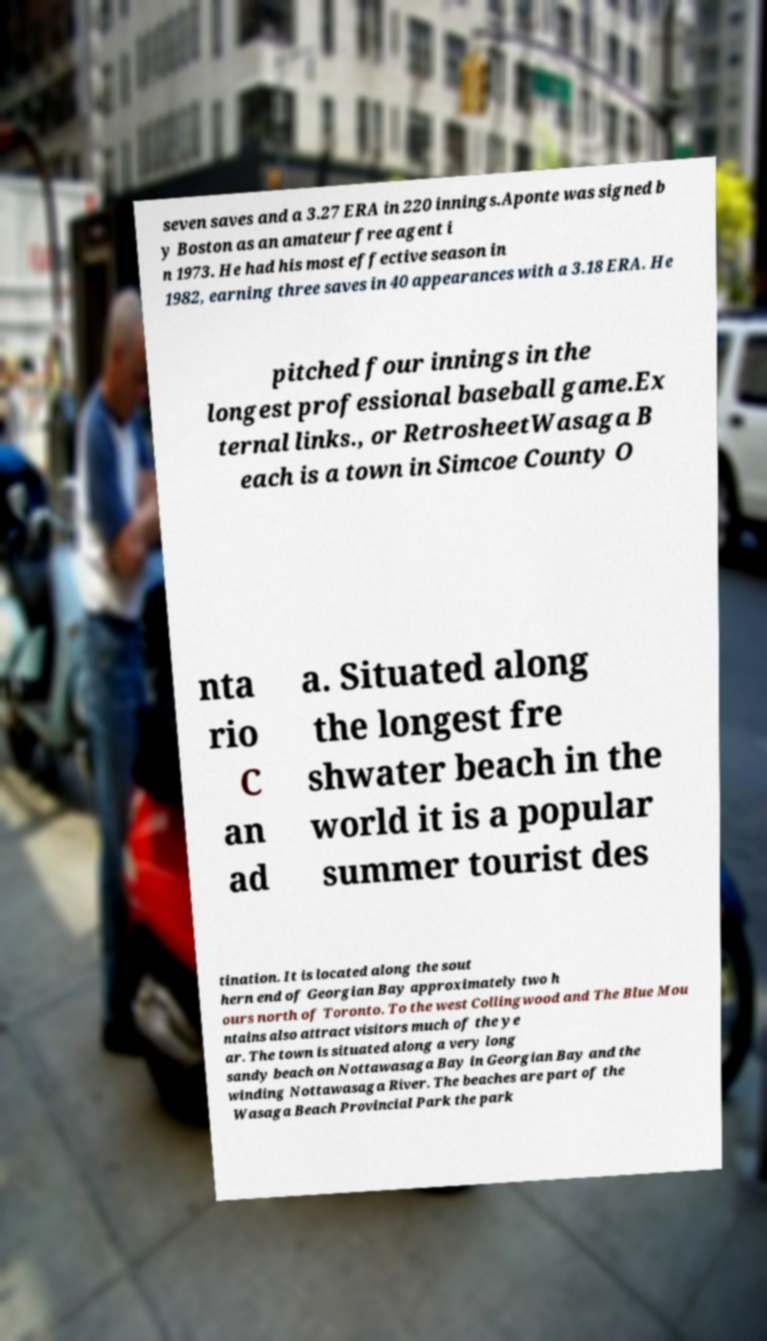Please read and relay the text visible in this image. What does it say? seven saves and a 3.27 ERA in 220 innings.Aponte was signed b y Boston as an amateur free agent i n 1973. He had his most effective season in 1982, earning three saves in 40 appearances with a 3.18 ERA. He pitched four innings in the longest professional baseball game.Ex ternal links., or RetrosheetWasaga B each is a town in Simcoe County O nta rio C an ad a. Situated along the longest fre shwater beach in the world it is a popular summer tourist des tination. It is located along the sout hern end of Georgian Bay approximately two h ours north of Toronto. To the west Collingwood and The Blue Mou ntains also attract visitors much of the ye ar. The town is situated along a very long sandy beach on Nottawasaga Bay in Georgian Bay and the winding Nottawasaga River. The beaches are part of the Wasaga Beach Provincial Park the park 